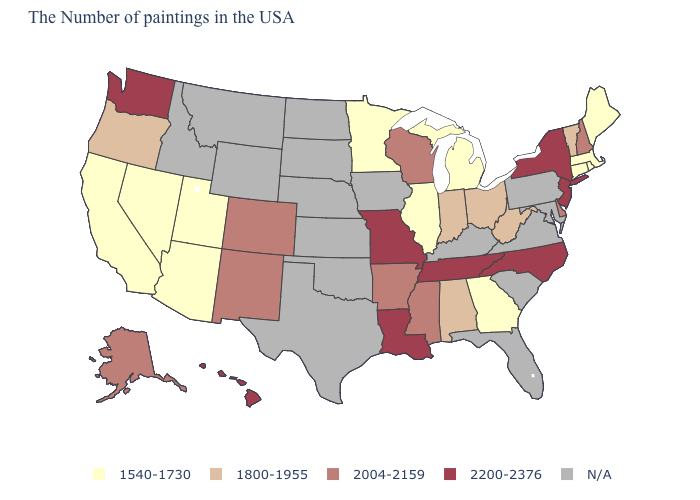What is the value of New Hampshire?
Keep it brief. 2004-2159. What is the value of Alabama?
Short answer required. 1800-1955. Name the states that have a value in the range 2004-2159?
Concise answer only. New Hampshire, Delaware, Wisconsin, Mississippi, Arkansas, Colorado, New Mexico, Alaska. What is the value of California?
Be succinct. 1540-1730. Name the states that have a value in the range 1540-1730?
Short answer required. Maine, Massachusetts, Rhode Island, Connecticut, Georgia, Michigan, Illinois, Minnesota, Utah, Arizona, Nevada, California. What is the value of Maine?
Keep it brief. 1540-1730. What is the lowest value in the USA?
Be succinct. 1540-1730. Name the states that have a value in the range 1540-1730?
Give a very brief answer. Maine, Massachusetts, Rhode Island, Connecticut, Georgia, Michigan, Illinois, Minnesota, Utah, Arizona, Nevada, California. What is the lowest value in the South?
Give a very brief answer. 1540-1730. What is the highest value in the USA?
Give a very brief answer. 2200-2376. What is the value of Oklahoma?
Concise answer only. N/A. What is the highest value in the West ?
Short answer required. 2200-2376. 